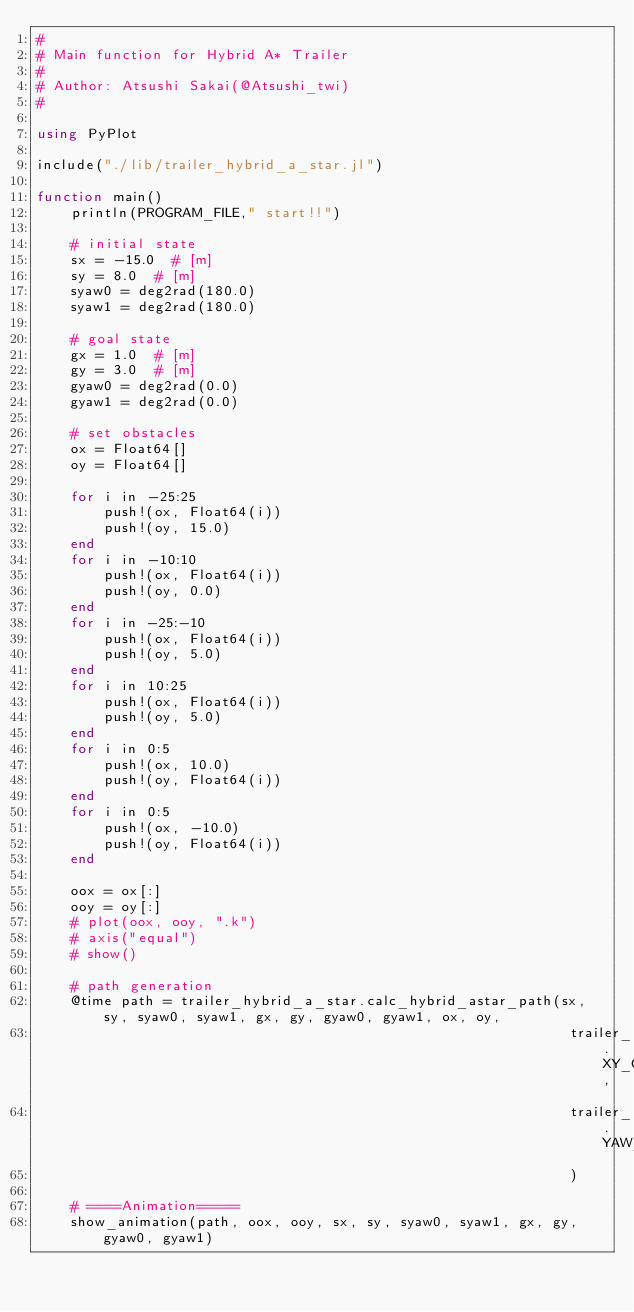<code> <loc_0><loc_0><loc_500><loc_500><_Julia_>#
# Main function for Hybrid A* Trailer 
# 
# Author: Atsushi Sakai(@Atsushi_twi)
#

using PyPlot

include("./lib/trailer_hybrid_a_star.jl")

function main()
    println(PROGRAM_FILE," start!!")

    # initial state
    sx = -15.0  # [m]
    sy = 8.0  # [m]
    syaw0 = deg2rad(180.0)
    syaw1 = deg2rad(180.0)

    # goal state
    gx = 1.0  # [m]
    gy = 3.0  # [m]
    gyaw0 = deg2rad(0.0)
    gyaw1 = deg2rad(0.0)

    # set obstacles
    ox = Float64[]
    oy = Float64[]

    for i in -25:25
        push!(ox, Float64(i))
        push!(oy, 15.0)
    end
    for i in -10:10
        push!(ox, Float64(i))
        push!(oy, 0.0)
    end
    for i in -25:-10
        push!(ox, Float64(i))
        push!(oy, 5.0)
    end
    for i in 10:25
        push!(ox, Float64(i))
        push!(oy, 5.0)
    end
    for i in 0:5
        push!(ox, 10.0)
        push!(oy, Float64(i))
    end
    for i in 0:5
        push!(ox, -10.0)
        push!(oy, Float64(i))
    end
 
    oox = ox[:]
    ooy = oy[:]
    # plot(oox, ooy, ".k")
    # axis("equal")
    # show()

    # path generation
    @time path = trailer_hybrid_a_star.calc_hybrid_astar_path(sx, sy, syaw0, syaw1, gx, gy, gyaw0, gyaw1, ox, oy,
                                                               trailer_hybrid_a_star.XY_GRID_RESOLUTION,
                                                               trailer_hybrid_a_star.YAW_GRID_RESOLUTION
                                                               )

    # ====Animation=====
    show_animation(path, oox, ooy, sx, sy, syaw0, syaw1, gx, gy, gyaw0, gyaw1)
</code> 